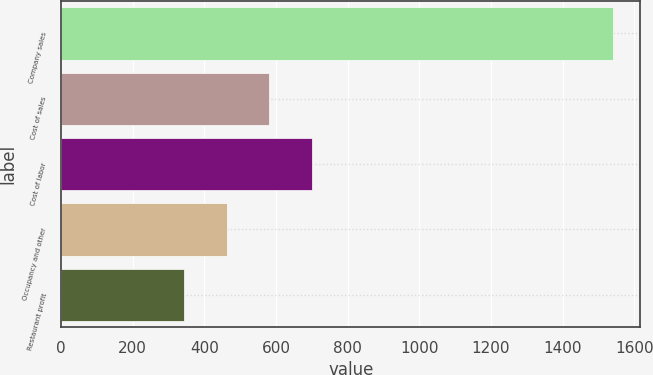Convert chart. <chart><loc_0><loc_0><loc_500><loc_500><bar_chart><fcel>Company sales<fcel>Cost of sales<fcel>Cost of labor<fcel>Occupancy and other<fcel>Restaurant profit<nl><fcel>1540<fcel>581.6<fcel>701.4<fcel>461.8<fcel>342<nl></chart> 